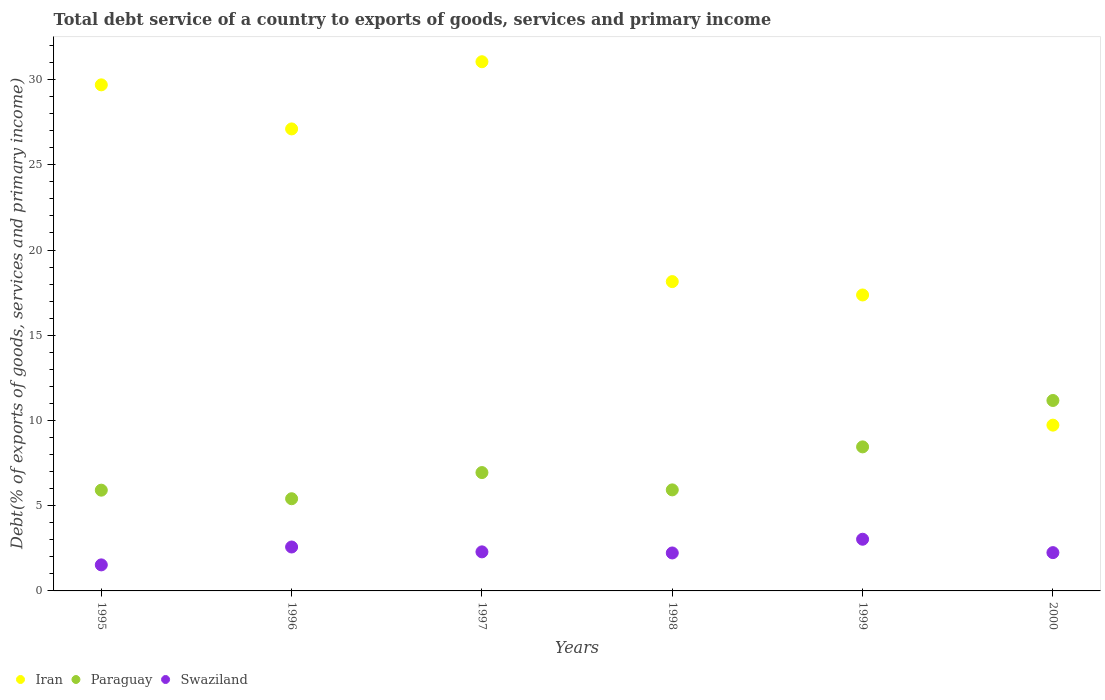How many different coloured dotlines are there?
Offer a terse response. 3. What is the total debt service in Iran in 1996?
Ensure brevity in your answer.  27.11. Across all years, what is the maximum total debt service in Iran?
Your response must be concise. 31.05. Across all years, what is the minimum total debt service in Paraguay?
Offer a very short reply. 5.41. In which year was the total debt service in Swaziland maximum?
Your answer should be compact. 1999. In which year was the total debt service in Swaziland minimum?
Make the answer very short. 1995. What is the total total debt service in Iran in the graph?
Keep it short and to the point. 133.08. What is the difference between the total debt service in Iran in 1995 and that in 1997?
Provide a short and direct response. -1.36. What is the difference between the total debt service in Paraguay in 1997 and the total debt service in Swaziland in 1999?
Make the answer very short. 3.91. What is the average total debt service in Iran per year?
Your response must be concise. 22.18. In the year 1997, what is the difference between the total debt service in Iran and total debt service in Swaziland?
Make the answer very short. 28.76. What is the ratio of the total debt service in Swaziland in 1995 to that in 2000?
Your answer should be very brief. 0.68. Is the total debt service in Iran in 1996 less than that in 1999?
Provide a short and direct response. No. Is the difference between the total debt service in Iran in 1996 and 1998 greater than the difference between the total debt service in Swaziland in 1996 and 1998?
Your answer should be compact. Yes. What is the difference between the highest and the second highest total debt service in Iran?
Give a very brief answer. 1.36. What is the difference between the highest and the lowest total debt service in Iran?
Keep it short and to the point. 21.32. In how many years, is the total debt service in Paraguay greater than the average total debt service in Paraguay taken over all years?
Offer a very short reply. 2. Is the sum of the total debt service in Paraguay in 1997 and 1999 greater than the maximum total debt service in Swaziland across all years?
Offer a very short reply. Yes. Is it the case that in every year, the sum of the total debt service in Iran and total debt service in Swaziland  is greater than the total debt service in Paraguay?
Ensure brevity in your answer.  Yes. Is the total debt service in Swaziland strictly greater than the total debt service in Paraguay over the years?
Offer a terse response. No. Is the total debt service in Iran strictly less than the total debt service in Swaziland over the years?
Ensure brevity in your answer.  No. How many years are there in the graph?
Your answer should be very brief. 6. What is the difference between two consecutive major ticks on the Y-axis?
Offer a very short reply. 5. Does the graph contain grids?
Make the answer very short. No. How are the legend labels stacked?
Your answer should be compact. Horizontal. What is the title of the graph?
Give a very brief answer. Total debt service of a country to exports of goods, services and primary income. Does "Syrian Arab Republic" appear as one of the legend labels in the graph?
Provide a succinct answer. No. What is the label or title of the X-axis?
Ensure brevity in your answer.  Years. What is the label or title of the Y-axis?
Ensure brevity in your answer.  Debt(% of exports of goods, services and primary income). What is the Debt(% of exports of goods, services and primary income) in Iran in 1995?
Your answer should be compact. 29.69. What is the Debt(% of exports of goods, services and primary income) in Paraguay in 1995?
Keep it short and to the point. 5.91. What is the Debt(% of exports of goods, services and primary income) of Swaziland in 1995?
Make the answer very short. 1.53. What is the Debt(% of exports of goods, services and primary income) in Iran in 1996?
Your response must be concise. 27.11. What is the Debt(% of exports of goods, services and primary income) of Paraguay in 1996?
Provide a short and direct response. 5.41. What is the Debt(% of exports of goods, services and primary income) in Swaziland in 1996?
Provide a succinct answer. 2.58. What is the Debt(% of exports of goods, services and primary income) of Iran in 1997?
Offer a terse response. 31.05. What is the Debt(% of exports of goods, services and primary income) in Paraguay in 1997?
Provide a short and direct response. 6.94. What is the Debt(% of exports of goods, services and primary income) of Swaziland in 1997?
Your answer should be compact. 2.29. What is the Debt(% of exports of goods, services and primary income) of Iran in 1998?
Offer a very short reply. 18.15. What is the Debt(% of exports of goods, services and primary income) of Paraguay in 1998?
Your response must be concise. 5.93. What is the Debt(% of exports of goods, services and primary income) in Swaziland in 1998?
Provide a succinct answer. 2.23. What is the Debt(% of exports of goods, services and primary income) of Iran in 1999?
Make the answer very short. 17.36. What is the Debt(% of exports of goods, services and primary income) of Paraguay in 1999?
Provide a short and direct response. 8.45. What is the Debt(% of exports of goods, services and primary income) of Swaziland in 1999?
Offer a terse response. 3.03. What is the Debt(% of exports of goods, services and primary income) in Iran in 2000?
Provide a short and direct response. 9.73. What is the Debt(% of exports of goods, services and primary income) of Paraguay in 2000?
Give a very brief answer. 11.17. What is the Debt(% of exports of goods, services and primary income) of Swaziland in 2000?
Your response must be concise. 2.25. Across all years, what is the maximum Debt(% of exports of goods, services and primary income) in Iran?
Offer a terse response. 31.05. Across all years, what is the maximum Debt(% of exports of goods, services and primary income) of Paraguay?
Your response must be concise. 11.17. Across all years, what is the maximum Debt(% of exports of goods, services and primary income) of Swaziland?
Provide a short and direct response. 3.03. Across all years, what is the minimum Debt(% of exports of goods, services and primary income) in Iran?
Offer a terse response. 9.73. Across all years, what is the minimum Debt(% of exports of goods, services and primary income) in Paraguay?
Provide a short and direct response. 5.41. Across all years, what is the minimum Debt(% of exports of goods, services and primary income) in Swaziland?
Make the answer very short. 1.53. What is the total Debt(% of exports of goods, services and primary income) in Iran in the graph?
Your response must be concise. 133.08. What is the total Debt(% of exports of goods, services and primary income) of Paraguay in the graph?
Make the answer very short. 43.82. What is the total Debt(% of exports of goods, services and primary income) of Swaziland in the graph?
Ensure brevity in your answer.  13.9. What is the difference between the Debt(% of exports of goods, services and primary income) of Iran in 1995 and that in 1996?
Offer a very short reply. 2.59. What is the difference between the Debt(% of exports of goods, services and primary income) of Paraguay in 1995 and that in 1996?
Offer a terse response. 0.5. What is the difference between the Debt(% of exports of goods, services and primary income) in Swaziland in 1995 and that in 1996?
Provide a short and direct response. -1.05. What is the difference between the Debt(% of exports of goods, services and primary income) in Iran in 1995 and that in 1997?
Your answer should be compact. -1.36. What is the difference between the Debt(% of exports of goods, services and primary income) of Paraguay in 1995 and that in 1997?
Give a very brief answer. -1.03. What is the difference between the Debt(% of exports of goods, services and primary income) in Swaziland in 1995 and that in 1997?
Provide a succinct answer. -0.76. What is the difference between the Debt(% of exports of goods, services and primary income) of Iran in 1995 and that in 1998?
Offer a terse response. 11.54. What is the difference between the Debt(% of exports of goods, services and primary income) of Paraguay in 1995 and that in 1998?
Keep it short and to the point. -0.02. What is the difference between the Debt(% of exports of goods, services and primary income) of Swaziland in 1995 and that in 1998?
Provide a succinct answer. -0.7. What is the difference between the Debt(% of exports of goods, services and primary income) in Iran in 1995 and that in 1999?
Offer a very short reply. 12.33. What is the difference between the Debt(% of exports of goods, services and primary income) of Paraguay in 1995 and that in 1999?
Offer a terse response. -2.54. What is the difference between the Debt(% of exports of goods, services and primary income) in Swaziland in 1995 and that in 1999?
Give a very brief answer. -1.5. What is the difference between the Debt(% of exports of goods, services and primary income) in Iran in 1995 and that in 2000?
Your answer should be very brief. 19.96. What is the difference between the Debt(% of exports of goods, services and primary income) in Paraguay in 1995 and that in 2000?
Your answer should be compact. -5.26. What is the difference between the Debt(% of exports of goods, services and primary income) in Swaziland in 1995 and that in 2000?
Make the answer very short. -0.72. What is the difference between the Debt(% of exports of goods, services and primary income) in Iran in 1996 and that in 1997?
Offer a terse response. -3.94. What is the difference between the Debt(% of exports of goods, services and primary income) in Paraguay in 1996 and that in 1997?
Ensure brevity in your answer.  -1.54. What is the difference between the Debt(% of exports of goods, services and primary income) of Swaziland in 1996 and that in 1997?
Your answer should be very brief. 0.29. What is the difference between the Debt(% of exports of goods, services and primary income) in Iran in 1996 and that in 1998?
Keep it short and to the point. 8.96. What is the difference between the Debt(% of exports of goods, services and primary income) of Paraguay in 1996 and that in 1998?
Your answer should be compact. -0.52. What is the difference between the Debt(% of exports of goods, services and primary income) in Swaziland in 1996 and that in 1998?
Make the answer very short. 0.35. What is the difference between the Debt(% of exports of goods, services and primary income) of Iran in 1996 and that in 1999?
Ensure brevity in your answer.  9.74. What is the difference between the Debt(% of exports of goods, services and primary income) of Paraguay in 1996 and that in 1999?
Your answer should be compact. -3.04. What is the difference between the Debt(% of exports of goods, services and primary income) in Swaziland in 1996 and that in 1999?
Keep it short and to the point. -0.46. What is the difference between the Debt(% of exports of goods, services and primary income) in Iran in 1996 and that in 2000?
Your answer should be very brief. 17.38. What is the difference between the Debt(% of exports of goods, services and primary income) of Paraguay in 1996 and that in 2000?
Offer a very short reply. -5.76. What is the difference between the Debt(% of exports of goods, services and primary income) in Swaziland in 1996 and that in 2000?
Provide a succinct answer. 0.33. What is the difference between the Debt(% of exports of goods, services and primary income) of Iran in 1997 and that in 1998?
Provide a succinct answer. 12.9. What is the difference between the Debt(% of exports of goods, services and primary income) of Paraguay in 1997 and that in 1998?
Offer a terse response. 1.02. What is the difference between the Debt(% of exports of goods, services and primary income) in Swaziland in 1997 and that in 1998?
Keep it short and to the point. 0.06. What is the difference between the Debt(% of exports of goods, services and primary income) of Iran in 1997 and that in 1999?
Your answer should be compact. 13.68. What is the difference between the Debt(% of exports of goods, services and primary income) of Paraguay in 1997 and that in 1999?
Your answer should be compact. -1.51. What is the difference between the Debt(% of exports of goods, services and primary income) in Swaziland in 1997 and that in 1999?
Your answer should be compact. -0.74. What is the difference between the Debt(% of exports of goods, services and primary income) in Iran in 1997 and that in 2000?
Provide a succinct answer. 21.32. What is the difference between the Debt(% of exports of goods, services and primary income) in Paraguay in 1997 and that in 2000?
Your answer should be compact. -4.23. What is the difference between the Debt(% of exports of goods, services and primary income) of Swaziland in 1997 and that in 2000?
Make the answer very short. 0.04. What is the difference between the Debt(% of exports of goods, services and primary income) of Iran in 1998 and that in 1999?
Your answer should be compact. 0.78. What is the difference between the Debt(% of exports of goods, services and primary income) in Paraguay in 1998 and that in 1999?
Offer a terse response. -2.52. What is the difference between the Debt(% of exports of goods, services and primary income) in Swaziland in 1998 and that in 1999?
Give a very brief answer. -0.81. What is the difference between the Debt(% of exports of goods, services and primary income) of Iran in 1998 and that in 2000?
Offer a very short reply. 8.42. What is the difference between the Debt(% of exports of goods, services and primary income) of Paraguay in 1998 and that in 2000?
Give a very brief answer. -5.25. What is the difference between the Debt(% of exports of goods, services and primary income) of Swaziland in 1998 and that in 2000?
Your answer should be compact. -0.02. What is the difference between the Debt(% of exports of goods, services and primary income) of Iran in 1999 and that in 2000?
Ensure brevity in your answer.  7.64. What is the difference between the Debt(% of exports of goods, services and primary income) of Paraguay in 1999 and that in 2000?
Your response must be concise. -2.72. What is the difference between the Debt(% of exports of goods, services and primary income) of Swaziland in 1999 and that in 2000?
Your answer should be compact. 0.79. What is the difference between the Debt(% of exports of goods, services and primary income) in Iran in 1995 and the Debt(% of exports of goods, services and primary income) in Paraguay in 1996?
Your response must be concise. 24.28. What is the difference between the Debt(% of exports of goods, services and primary income) in Iran in 1995 and the Debt(% of exports of goods, services and primary income) in Swaziland in 1996?
Your response must be concise. 27.11. What is the difference between the Debt(% of exports of goods, services and primary income) in Paraguay in 1995 and the Debt(% of exports of goods, services and primary income) in Swaziland in 1996?
Provide a short and direct response. 3.33. What is the difference between the Debt(% of exports of goods, services and primary income) in Iran in 1995 and the Debt(% of exports of goods, services and primary income) in Paraguay in 1997?
Offer a terse response. 22.75. What is the difference between the Debt(% of exports of goods, services and primary income) in Iran in 1995 and the Debt(% of exports of goods, services and primary income) in Swaziland in 1997?
Offer a terse response. 27.4. What is the difference between the Debt(% of exports of goods, services and primary income) of Paraguay in 1995 and the Debt(% of exports of goods, services and primary income) of Swaziland in 1997?
Make the answer very short. 3.62. What is the difference between the Debt(% of exports of goods, services and primary income) of Iran in 1995 and the Debt(% of exports of goods, services and primary income) of Paraguay in 1998?
Provide a short and direct response. 23.76. What is the difference between the Debt(% of exports of goods, services and primary income) in Iran in 1995 and the Debt(% of exports of goods, services and primary income) in Swaziland in 1998?
Offer a very short reply. 27.46. What is the difference between the Debt(% of exports of goods, services and primary income) of Paraguay in 1995 and the Debt(% of exports of goods, services and primary income) of Swaziland in 1998?
Provide a succinct answer. 3.68. What is the difference between the Debt(% of exports of goods, services and primary income) in Iran in 1995 and the Debt(% of exports of goods, services and primary income) in Paraguay in 1999?
Keep it short and to the point. 21.24. What is the difference between the Debt(% of exports of goods, services and primary income) of Iran in 1995 and the Debt(% of exports of goods, services and primary income) of Swaziland in 1999?
Provide a short and direct response. 26.66. What is the difference between the Debt(% of exports of goods, services and primary income) of Paraguay in 1995 and the Debt(% of exports of goods, services and primary income) of Swaziland in 1999?
Offer a very short reply. 2.88. What is the difference between the Debt(% of exports of goods, services and primary income) in Iran in 1995 and the Debt(% of exports of goods, services and primary income) in Paraguay in 2000?
Provide a short and direct response. 18.52. What is the difference between the Debt(% of exports of goods, services and primary income) in Iran in 1995 and the Debt(% of exports of goods, services and primary income) in Swaziland in 2000?
Provide a succinct answer. 27.44. What is the difference between the Debt(% of exports of goods, services and primary income) in Paraguay in 1995 and the Debt(% of exports of goods, services and primary income) in Swaziland in 2000?
Keep it short and to the point. 3.66. What is the difference between the Debt(% of exports of goods, services and primary income) of Iran in 1996 and the Debt(% of exports of goods, services and primary income) of Paraguay in 1997?
Ensure brevity in your answer.  20.16. What is the difference between the Debt(% of exports of goods, services and primary income) in Iran in 1996 and the Debt(% of exports of goods, services and primary income) in Swaziland in 1997?
Your answer should be very brief. 24.81. What is the difference between the Debt(% of exports of goods, services and primary income) of Paraguay in 1996 and the Debt(% of exports of goods, services and primary income) of Swaziland in 1997?
Provide a short and direct response. 3.12. What is the difference between the Debt(% of exports of goods, services and primary income) of Iran in 1996 and the Debt(% of exports of goods, services and primary income) of Paraguay in 1998?
Ensure brevity in your answer.  21.18. What is the difference between the Debt(% of exports of goods, services and primary income) in Iran in 1996 and the Debt(% of exports of goods, services and primary income) in Swaziland in 1998?
Offer a terse response. 24.88. What is the difference between the Debt(% of exports of goods, services and primary income) of Paraguay in 1996 and the Debt(% of exports of goods, services and primary income) of Swaziland in 1998?
Provide a short and direct response. 3.18. What is the difference between the Debt(% of exports of goods, services and primary income) of Iran in 1996 and the Debt(% of exports of goods, services and primary income) of Paraguay in 1999?
Provide a short and direct response. 18.65. What is the difference between the Debt(% of exports of goods, services and primary income) in Iran in 1996 and the Debt(% of exports of goods, services and primary income) in Swaziland in 1999?
Offer a very short reply. 24.07. What is the difference between the Debt(% of exports of goods, services and primary income) of Paraguay in 1996 and the Debt(% of exports of goods, services and primary income) of Swaziland in 1999?
Offer a very short reply. 2.38. What is the difference between the Debt(% of exports of goods, services and primary income) of Iran in 1996 and the Debt(% of exports of goods, services and primary income) of Paraguay in 2000?
Your answer should be compact. 15.93. What is the difference between the Debt(% of exports of goods, services and primary income) of Iran in 1996 and the Debt(% of exports of goods, services and primary income) of Swaziland in 2000?
Provide a succinct answer. 24.86. What is the difference between the Debt(% of exports of goods, services and primary income) of Paraguay in 1996 and the Debt(% of exports of goods, services and primary income) of Swaziland in 2000?
Provide a succinct answer. 3.16. What is the difference between the Debt(% of exports of goods, services and primary income) of Iran in 1997 and the Debt(% of exports of goods, services and primary income) of Paraguay in 1998?
Keep it short and to the point. 25.12. What is the difference between the Debt(% of exports of goods, services and primary income) of Iran in 1997 and the Debt(% of exports of goods, services and primary income) of Swaziland in 1998?
Your answer should be very brief. 28.82. What is the difference between the Debt(% of exports of goods, services and primary income) of Paraguay in 1997 and the Debt(% of exports of goods, services and primary income) of Swaziland in 1998?
Offer a very short reply. 4.72. What is the difference between the Debt(% of exports of goods, services and primary income) in Iran in 1997 and the Debt(% of exports of goods, services and primary income) in Paraguay in 1999?
Provide a short and direct response. 22.6. What is the difference between the Debt(% of exports of goods, services and primary income) of Iran in 1997 and the Debt(% of exports of goods, services and primary income) of Swaziland in 1999?
Give a very brief answer. 28.02. What is the difference between the Debt(% of exports of goods, services and primary income) in Paraguay in 1997 and the Debt(% of exports of goods, services and primary income) in Swaziland in 1999?
Keep it short and to the point. 3.91. What is the difference between the Debt(% of exports of goods, services and primary income) in Iran in 1997 and the Debt(% of exports of goods, services and primary income) in Paraguay in 2000?
Make the answer very short. 19.87. What is the difference between the Debt(% of exports of goods, services and primary income) in Iran in 1997 and the Debt(% of exports of goods, services and primary income) in Swaziland in 2000?
Ensure brevity in your answer.  28.8. What is the difference between the Debt(% of exports of goods, services and primary income) in Paraguay in 1997 and the Debt(% of exports of goods, services and primary income) in Swaziland in 2000?
Offer a very short reply. 4.7. What is the difference between the Debt(% of exports of goods, services and primary income) in Iran in 1998 and the Debt(% of exports of goods, services and primary income) in Paraguay in 1999?
Give a very brief answer. 9.7. What is the difference between the Debt(% of exports of goods, services and primary income) in Iran in 1998 and the Debt(% of exports of goods, services and primary income) in Swaziland in 1999?
Your answer should be compact. 15.12. What is the difference between the Debt(% of exports of goods, services and primary income) of Paraguay in 1998 and the Debt(% of exports of goods, services and primary income) of Swaziland in 1999?
Provide a short and direct response. 2.9. What is the difference between the Debt(% of exports of goods, services and primary income) in Iran in 1998 and the Debt(% of exports of goods, services and primary income) in Paraguay in 2000?
Ensure brevity in your answer.  6.97. What is the difference between the Debt(% of exports of goods, services and primary income) of Iran in 1998 and the Debt(% of exports of goods, services and primary income) of Swaziland in 2000?
Provide a succinct answer. 15.9. What is the difference between the Debt(% of exports of goods, services and primary income) of Paraguay in 1998 and the Debt(% of exports of goods, services and primary income) of Swaziland in 2000?
Ensure brevity in your answer.  3.68. What is the difference between the Debt(% of exports of goods, services and primary income) in Iran in 1999 and the Debt(% of exports of goods, services and primary income) in Paraguay in 2000?
Your response must be concise. 6.19. What is the difference between the Debt(% of exports of goods, services and primary income) of Iran in 1999 and the Debt(% of exports of goods, services and primary income) of Swaziland in 2000?
Provide a short and direct response. 15.12. What is the difference between the Debt(% of exports of goods, services and primary income) in Paraguay in 1999 and the Debt(% of exports of goods, services and primary income) in Swaziland in 2000?
Offer a very short reply. 6.2. What is the average Debt(% of exports of goods, services and primary income) in Iran per year?
Your response must be concise. 22.18. What is the average Debt(% of exports of goods, services and primary income) in Paraguay per year?
Give a very brief answer. 7.3. What is the average Debt(% of exports of goods, services and primary income) in Swaziland per year?
Ensure brevity in your answer.  2.32. In the year 1995, what is the difference between the Debt(% of exports of goods, services and primary income) of Iran and Debt(% of exports of goods, services and primary income) of Paraguay?
Your response must be concise. 23.78. In the year 1995, what is the difference between the Debt(% of exports of goods, services and primary income) in Iran and Debt(% of exports of goods, services and primary income) in Swaziland?
Offer a very short reply. 28.16. In the year 1995, what is the difference between the Debt(% of exports of goods, services and primary income) of Paraguay and Debt(% of exports of goods, services and primary income) of Swaziland?
Offer a terse response. 4.38. In the year 1996, what is the difference between the Debt(% of exports of goods, services and primary income) of Iran and Debt(% of exports of goods, services and primary income) of Paraguay?
Provide a succinct answer. 21.7. In the year 1996, what is the difference between the Debt(% of exports of goods, services and primary income) of Iran and Debt(% of exports of goods, services and primary income) of Swaziland?
Your response must be concise. 24.53. In the year 1996, what is the difference between the Debt(% of exports of goods, services and primary income) in Paraguay and Debt(% of exports of goods, services and primary income) in Swaziland?
Offer a very short reply. 2.83. In the year 1997, what is the difference between the Debt(% of exports of goods, services and primary income) of Iran and Debt(% of exports of goods, services and primary income) of Paraguay?
Your answer should be compact. 24.1. In the year 1997, what is the difference between the Debt(% of exports of goods, services and primary income) in Iran and Debt(% of exports of goods, services and primary income) in Swaziland?
Provide a succinct answer. 28.76. In the year 1997, what is the difference between the Debt(% of exports of goods, services and primary income) of Paraguay and Debt(% of exports of goods, services and primary income) of Swaziland?
Ensure brevity in your answer.  4.65. In the year 1998, what is the difference between the Debt(% of exports of goods, services and primary income) of Iran and Debt(% of exports of goods, services and primary income) of Paraguay?
Your response must be concise. 12.22. In the year 1998, what is the difference between the Debt(% of exports of goods, services and primary income) in Iran and Debt(% of exports of goods, services and primary income) in Swaziland?
Your response must be concise. 15.92. In the year 1998, what is the difference between the Debt(% of exports of goods, services and primary income) in Paraguay and Debt(% of exports of goods, services and primary income) in Swaziland?
Make the answer very short. 3.7. In the year 1999, what is the difference between the Debt(% of exports of goods, services and primary income) in Iran and Debt(% of exports of goods, services and primary income) in Paraguay?
Provide a succinct answer. 8.91. In the year 1999, what is the difference between the Debt(% of exports of goods, services and primary income) of Iran and Debt(% of exports of goods, services and primary income) of Swaziland?
Ensure brevity in your answer.  14.33. In the year 1999, what is the difference between the Debt(% of exports of goods, services and primary income) of Paraguay and Debt(% of exports of goods, services and primary income) of Swaziland?
Give a very brief answer. 5.42. In the year 2000, what is the difference between the Debt(% of exports of goods, services and primary income) in Iran and Debt(% of exports of goods, services and primary income) in Paraguay?
Ensure brevity in your answer.  -1.45. In the year 2000, what is the difference between the Debt(% of exports of goods, services and primary income) of Iran and Debt(% of exports of goods, services and primary income) of Swaziland?
Provide a succinct answer. 7.48. In the year 2000, what is the difference between the Debt(% of exports of goods, services and primary income) in Paraguay and Debt(% of exports of goods, services and primary income) in Swaziland?
Ensure brevity in your answer.  8.93. What is the ratio of the Debt(% of exports of goods, services and primary income) in Iran in 1995 to that in 1996?
Provide a short and direct response. 1.1. What is the ratio of the Debt(% of exports of goods, services and primary income) of Paraguay in 1995 to that in 1996?
Your response must be concise. 1.09. What is the ratio of the Debt(% of exports of goods, services and primary income) in Swaziland in 1995 to that in 1996?
Offer a terse response. 0.59. What is the ratio of the Debt(% of exports of goods, services and primary income) in Iran in 1995 to that in 1997?
Your answer should be compact. 0.96. What is the ratio of the Debt(% of exports of goods, services and primary income) of Paraguay in 1995 to that in 1997?
Offer a very short reply. 0.85. What is the ratio of the Debt(% of exports of goods, services and primary income) in Swaziland in 1995 to that in 1997?
Provide a succinct answer. 0.67. What is the ratio of the Debt(% of exports of goods, services and primary income) in Iran in 1995 to that in 1998?
Make the answer very short. 1.64. What is the ratio of the Debt(% of exports of goods, services and primary income) of Swaziland in 1995 to that in 1998?
Provide a succinct answer. 0.69. What is the ratio of the Debt(% of exports of goods, services and primary income) of Iran in 1995 to that in 1999?
Offer a terse response. 1.71. What is the ratio of the Debt(% of exports of goods, services and primary income) in Paraguay in 1995 to that in 1999?
Your response must be concise. 0.7. What is the ratio of the Debt(% of exports of goods, services and primary income) in Swaziland in 1995 to that in 1999?
Offer a terse response. 0.5. What is the ratio of the Debt(% of exports of goods, services and primary income) of Iran in 1995 to that in 2000?
Your response must be concise. 3.05. What is the ratio of the Debt(% of exports of goods, services and primary income) in Paraguay in 1995 to that in 2000?
Offer a terse response. 0.53. What is the ratio of the Debt(% of exports of goods, services and primary income) in Swaziland in 1995 to that in 2000?
Provide a succinct answer. 0.68. What is the ratio of the Debt(% of exports of goods, services and primary income) of Iran in 1996 to that in 1997?
Ensure brevity in your answer.  0.87. What is the ratio of the Debt(% of exports of goods, services and primary income) in Paraguay in 1996 to that in 1997?
Provide a short and direct response. 0.78. What is the ratio of the Debt(% of exports of goods, services and primary income) in Swaziland in 1996 to that in 1997?
Your response must be concise. 1.12. What is the ratio of the Debt(% of exports of goods, services and primary income) of Iran in 1996 to that in 1998?
Provide a short and direct response. 1.49. What is the ratio of the Debt(% of exports of goods, services and primary income) in Paraguay in 1996 to that in 1998?
Keep it short and to the point. 0.91. What is the ratio of the Debt(% of exports of goods, services and primary income) of Swaziland in 1996 to that in 1998?
Your answer should be very brief. 1.16. What is the ratio of the Debt(% of exports of goods, services and primary income) of Iran in 1996 to that in 1999?
Keep it short and to the point. 1.56. What is the ratio of the Debt(% of exports of goods, services and primary income) of Paraguay in 1996 to that in 1999?
Provide a short and direct response. 0.64. What is the ratio of the Debt(% of exports of goods, services and primary income) of Swaziland in 1996 to that in 1999?
Your response must be concise. 0.85. What is the ratio of the Debt(% of exports of goods, services and primary income) in Iran in 1996 to that in 2000?
Your answer should be very brief. 2.79. What is the ratio of the Debt(% of exports of goods, services and primary income) in Paraguay in 1996 to that in 2000?
Ensure brevity in your answer.  0.48. What is the ratio of the Debt(% of exports of goods, services and primary income) of Swaziland in 1996 to that in 2000?
Your response must be concise. 1.15. What is the ratio of the Debt(% of exports of goods, services and primary income) in Iran in 1997 to that in 1998?
Offer a terse response. 1.71. What is the ratio of the Debt(% of exports of goods, services and primary income) in Paraguay in 1997 to that in 1998?
Your answer should be compact. 1.17. What is the ratio of the Debt(% of exports of goods, services and primary income) of Swaziland in 1997 to that in 1998?
Offer a very short reply. 1.03. What is the ratio of the Debt(% of exports of goods, services and primary income) of Iran in 1997 to that in 1999?
Ensure brevity in your answer.  1.79. What is the ratio of the Debt(% of exports of goods, services and primary income) in Paraguay in 1997 to that in 1999?
Your answer should be very brief. 0.82. What is the ratio of the Debt(% of exports of goods, services and primary income) of Swaziland in 1997 to that in 1999?
Keep it short and to the point. 0.76. What is the ratio of the Debt(% of exports of goods, services and primary income) of Iran in 1997 to that in 2000?
Offer a very short reply. 3.19. What is the ratio of the Debt(% of exports of goods, services and primary income) of Paraguay in 1997 to that in 2000?
Give a very brief answer. 0.62. What is the ratio of the Debt(% of exports of goods, services and primary income) in Swaziland in 1997 to that in 2000?
Ensure brevity in your answer.  1.02. What is the ratio of the Debt(% of exports of goods, services and primary income) of Iran in 1998 to that in 1999?
Provide a succinct answer. 1.05. What is the ratio of the Debt(% of exports of goods, services and primary income) in Paraguay in 1998 to that in 1999?
Offer a very short reply. 0.7. What is the ratio of the Debt(% of exports of goods, services and primary income) of Swaziland in 1998 to that in 1999?
Ensure brevity in your answer.  0.73. What is the ratio of the Debt(% of exports of goods, services and primary income) in Iran in 1998 to that in 2000?
Offer a terse response. 1.87. What is the ratio of the Debt(% of exports of goods, services and primary income) of Paraguay in 1998 to that in 2000?
Offer a very short reply. 0.53. What is the ratio of the Debt(% of exports of goods, services and primary income) in Iran in 1999 to that in 2000?
Provide a short and direct response. 1.79. What is the ratio of the Debt(% of exports of goods, services and primary income) in Paraguay in 1999 to that in 2000?
Make the answer very short. 0.76. What is the ratio of the Debt(% of exports of goods, services and primary income) of Swaziland in 1999 to that in 2000?
Your response must be concise. 1.35. What is the difference between the highest and the second highest Debt(% of exports of goods, services and primary income) in Iran?
Provide a succinct answer. 1.36. What is the difference between the highest and the second highest Debt(% of exports of goods, services and primary income) of Paraguay?
Give a very brief answer. 2.72. What is the difference between the highest and the second highest Debt(% of exports of goods, services and primary income) of Swaziland?
Provide a succinct answer. 0.46. What is the difference between the highest and the lowest Debt(% of exports of goods, services and primary income) in Iran?
Make the answer very short. 21.32. What is the difference between the highest and the lowest Debt(% of exports of goods, services and primary income) of Paraguay?
Keep it short and to the point. 5.76. What is the difference between the highest and the lowest Debt(% of exports of goods, services and primary income) in Swaziland?
Your answer should be very brief. 1.5. 